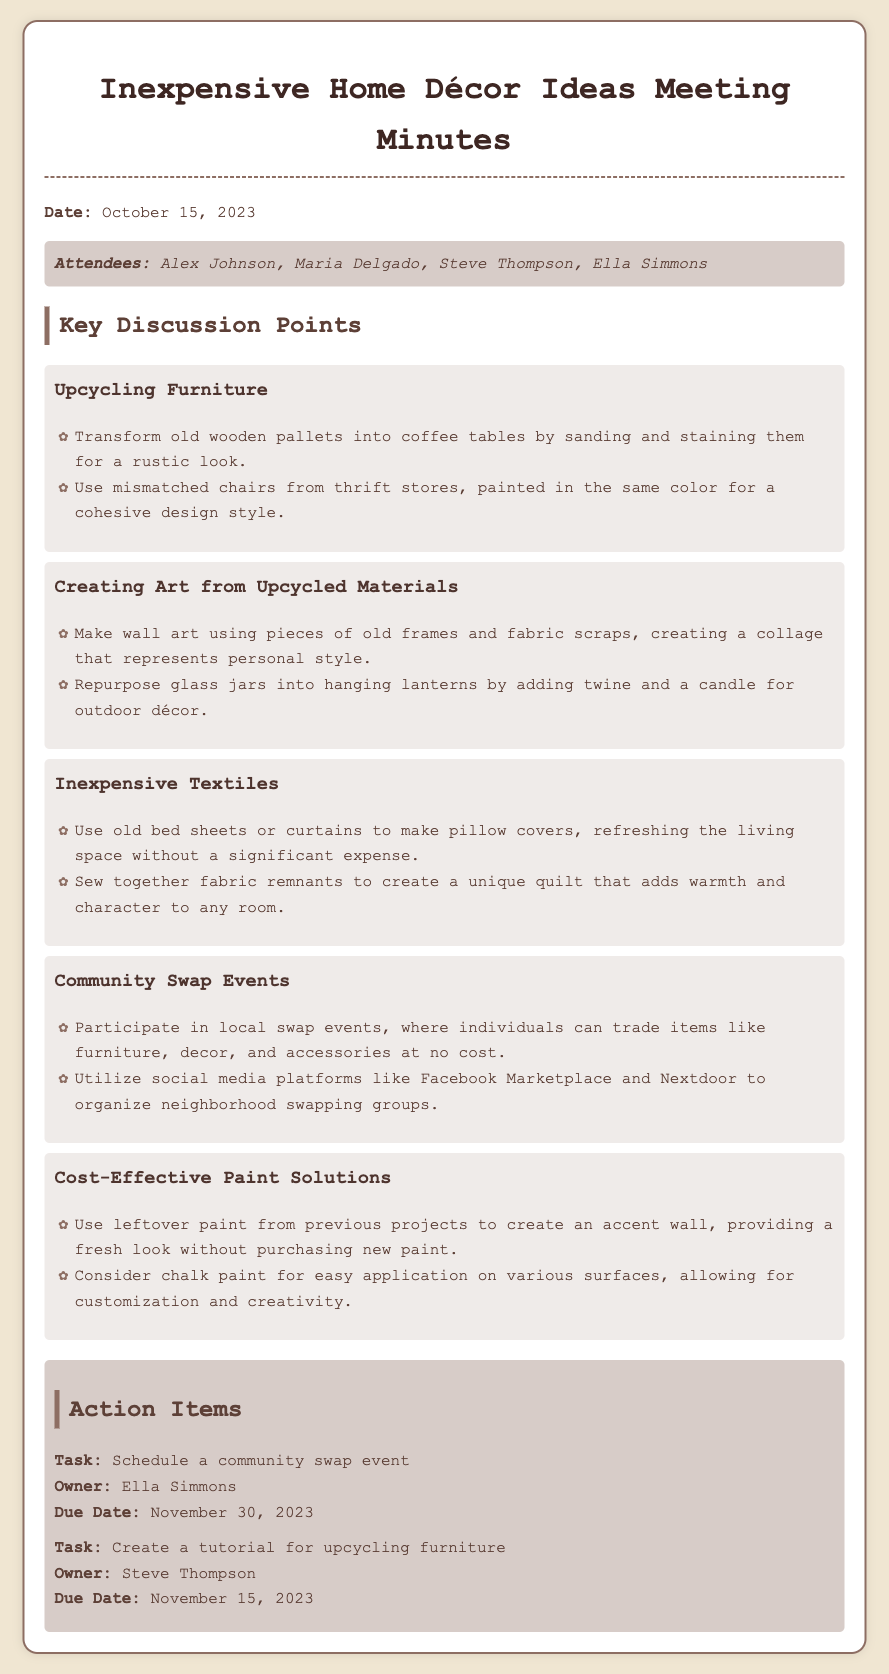What is the date of the meeting? The date of the meeting is presented right at the beginning of the document.
Answer: October 15, 2023 Who is the owner of the task to schedule a community swap event? The owner of the task is listed under the action items section in the document.
Answer: Ella Simmons How many key discussion points are listed? The number of key discussion points can be counted from the sections in the document.
Answer: Five What are old bed sheets repurposed into? This information is noted in the inexpensive textiles section regarding the use of old bed sheets.
Answer: Pillow covers What is one suggestion for cost-effective paint solutions? This is detailed in the key points section about paint solutions.
Answer: Use leftover paint Which attendee is responsible for creating a tutorial for upcycling furniture? The responsible person for this task is specified in the action items section.
Answer: Steve Thompson What event type is suggested for exchanging items at no cost? This is mentioned clearly in the community swap events section.
Answer: Swap events What color should mismatched chairs be painted for cohesiveness? The answer can be inferred from the discussion points on furniture.
Answer: Same color Where can neighborhood swapping groups be organized? The social media platforms are listed in the community swap events information.
Answer: Facebook Marketplace and Nextdoor 